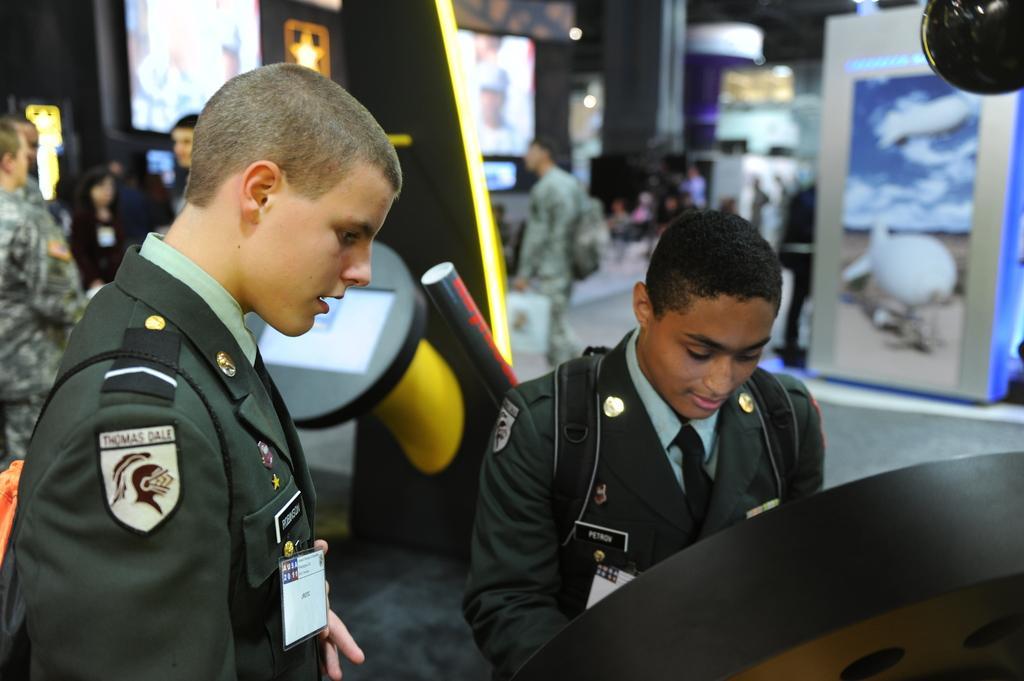Could you give a brief overview of what you see in this image? Here in this picture, in the front we can see two persons standing in front of something and behind them also we can see people standing here and there and we can see some machines present over there and we can see they are having ID cards on them. 